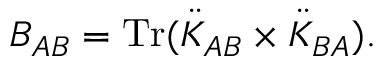Convert formula to latex. <formula><loc_0><loc_0><loc_500><loc_500>B _ { A B } = T r ( \ddot { K } _ { A B } \times \ddot { K } _ { B A } ) .</formula> 